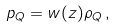<formula> <loc_0><loc_0><loc_500><loc_500>p _ { Q } = w ( z ) \rho _ { Q } \, ,</formula> 